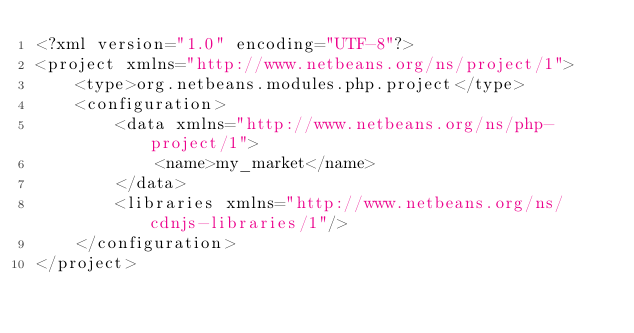Convert code to text. <code><loc_0><loc_0><loc_500><loc_500><_XML_><?xml version="1.0" encoding="UTF-8"?>
<project xmlns="http://www.netbeans.org/ns/project/1">
    <type>org.netbeans.modules.php.project</type>
    <configuration>
        <data xmlns="http://www.netbeans.org/ns/php-project/1">
            <name>my_market</name>
        </data>
        <libraries xmlns="http://www.netbeans.org/ns/cdnjs-libraries/1"/>
    </configuration>
</project>
</code> 